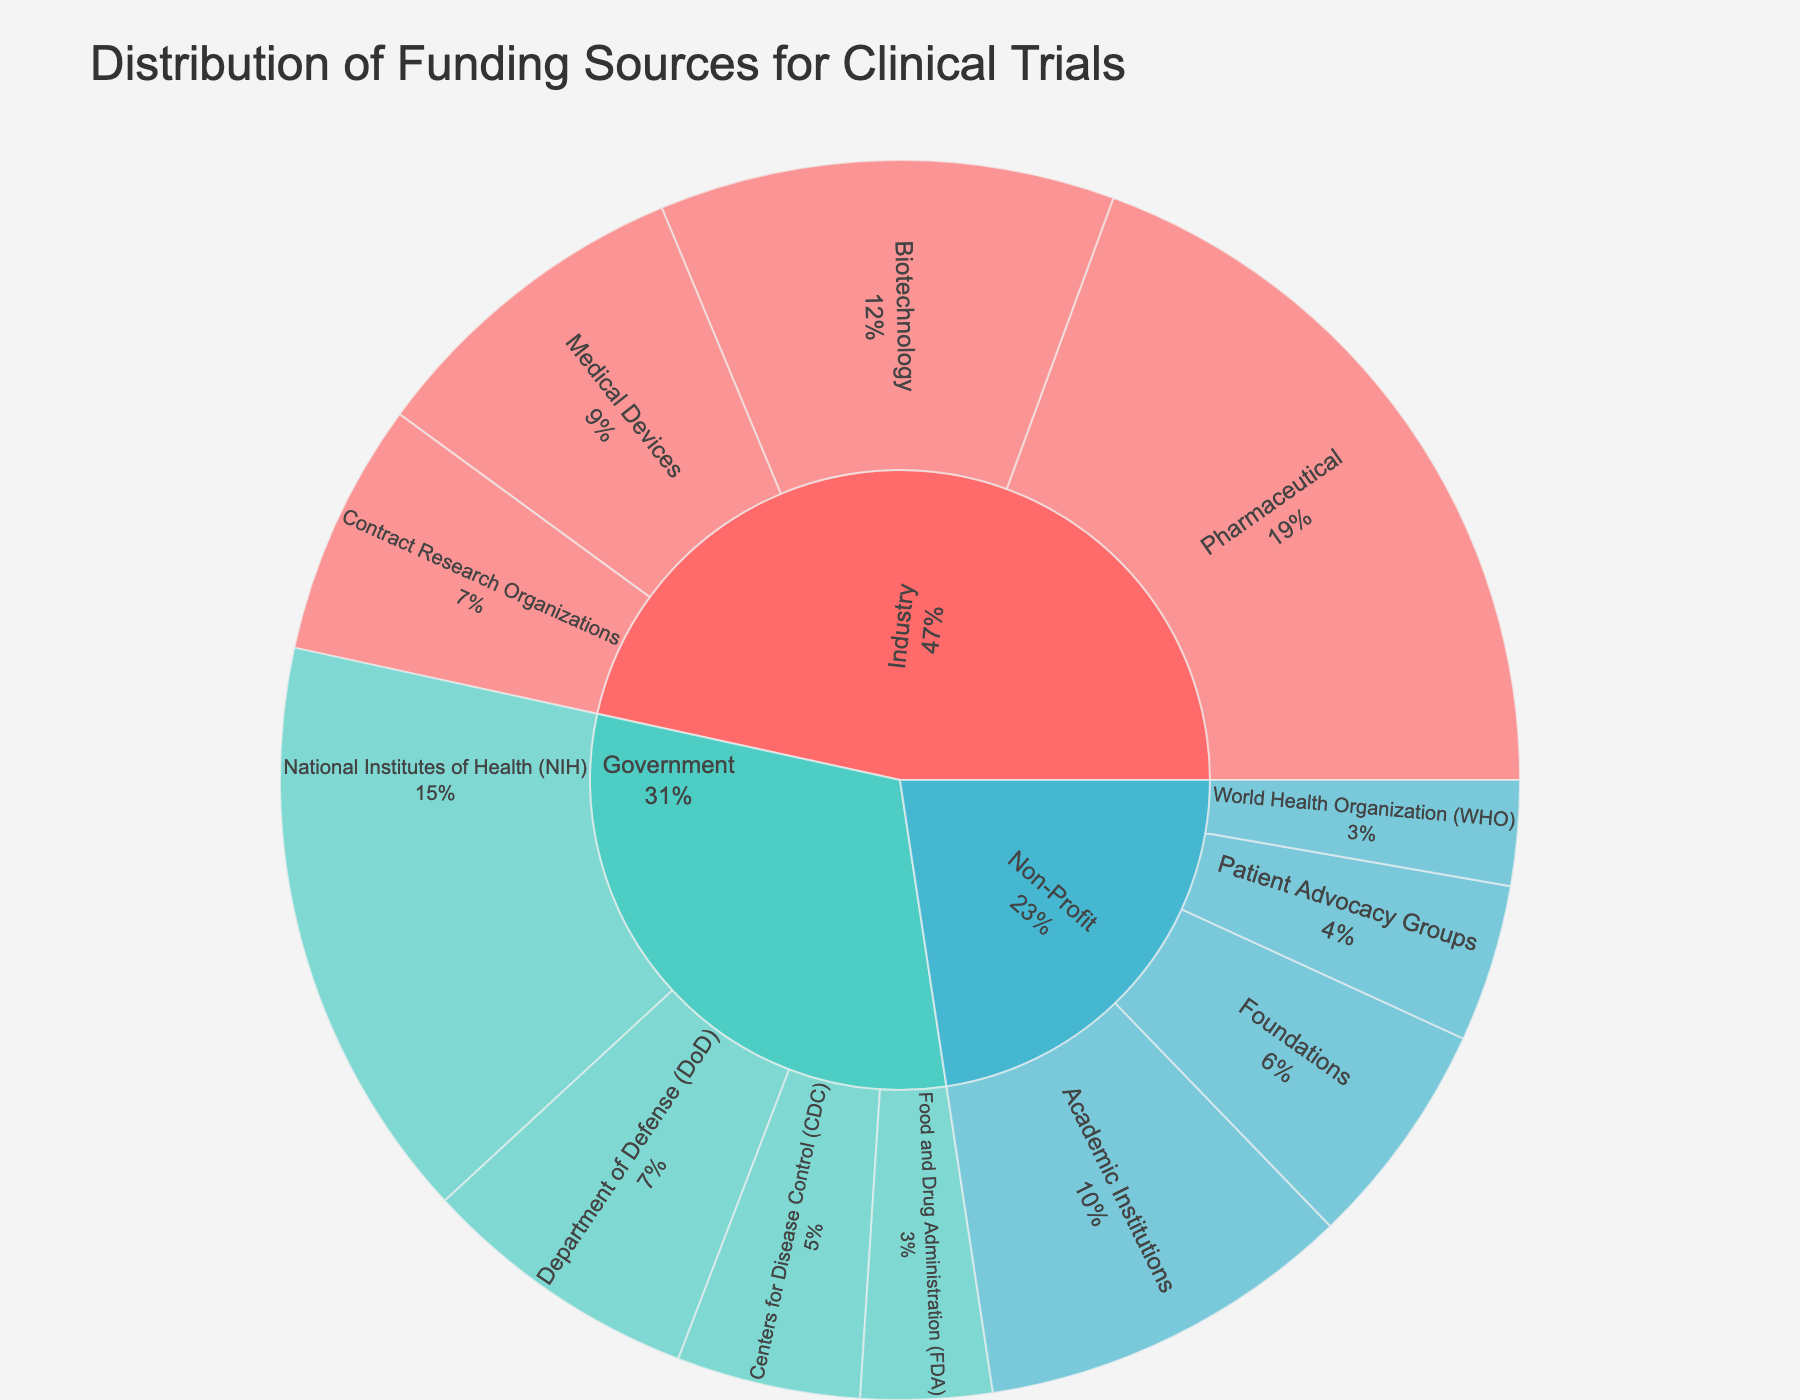What is the total funding amount from the non-profit sector? To find the total non-profit sector funding, add up the funding amounts from all subcategories under Non-Profit: Patient Advocacy Groups ($1,800,000), Academic Institutions ($4,300,000), Foundations ($2,600,000), and WHO ($1,200,000). So, the total is $1,800,000 + $4,300,000 + $2,600,000 + $1,200,000.
Answer: $9,900,000 Which subcategory within the industry sector has the largest funding amount? Look at the funding amounts for each subcategory under Industry: Pharmaceutical ($8,500,000), Biotechnology ($5,200,000), Medical Devices ($3,800,000), and Contract Research Organizations ($2,900,000). The subcategory with the largest funding is Pharmaceutical with $8,500,000.
Answer: Pharmaceutical Compare the total funding amount from the government sector to the total funding from the industry sector. Which one is greater and by how much? Calculate the total funding for each sector first. For Government: NIH ($6,700,000), DoD ($3,200,000), CDC ($2,100,000), FDA ($1,500,000). Total: $6,700,000 + $3,200,000 + $2,100,000 + $1,500,000 = $13,500,000. For Industry: Pharmaceutical ($8,500,000), Biotechnology ($5,200,000), Medical Devices ($3,800,000), Contract Research Organizations ($2,900,000). Total: $8,500,000 + $5,200,000 + $3,800,000 + $2,900,000 = $20,400,000. Compare the totals, Industry sector funding is greater by $20,400,000 - $13,500,000 = $6,900,000.
Answer: Industry is greater by $6,900,000 Which organization under the government sector provides the least amount of funding? Examine the funding amounts for each subcategory in Government: NIH ($6,700,000), DoD ($3,200,000), CDC ($2,100,000), FDA ($1,500,000). FDA provides the least amount of funding with $1,500,000.
Answer: FDA What is the funding percentage of Academic Institutions within the Non-Profit sector? To find the percentage, divide the funding for Academic Institutions ($4,300,000) by the total funding from Non-Profit ($9,900,000). Percentage = ($4,300,000 / $9,900,000) * 100.
Answer: Approximately 43.4% How does the funding from the Biotechnology subcategory compare with that from the Centers for Disease Control (CDC)? Compare the funding amounts directly: Biotechnology ($5,200,000) versus CDC ($2,100,000). Biotechnology funding is greater.
Answer: Biotechnology is greater Describe the color-coding of the sunburst plot. How can one distinguish between sectors based on colors? The sectors are color-coded: Industry is represented by a reddish color, Government by a teal color, and Non-Profit by a light blue color. These color distinctions help visually separate the sectors.
Answer: Different colors for different sectors What is the combined funding amount for Medical Devices and Contract Research Organizations within the Industry sector? Add their funding amounts: Medical Devices ($3,800,000) + Contract Research Organizations ($2,900,000). The combined amount is $3,800,000 + $2,900,000.
Answer: $6,700,000 Which sector has the second-highest total funding, and what is the total? First, sum up the funding for each sector. Industry: $20,400,000, Government: $13,500,000, Non-Profit: $9,900,000. The Government sector has the second-highest funding with $13,500,000.
Answer: Government with $13,500,000 How much more funding does the Pharmaceutical subcategory receive compared to the Department of Defense (DoD)? Compare the funding directly: Pharmaceutical ($8,500,000) and DoD ($3,200,000). Calculate the difference: $8,500,000 - $3,200,000.
Answer: $5,300,000 